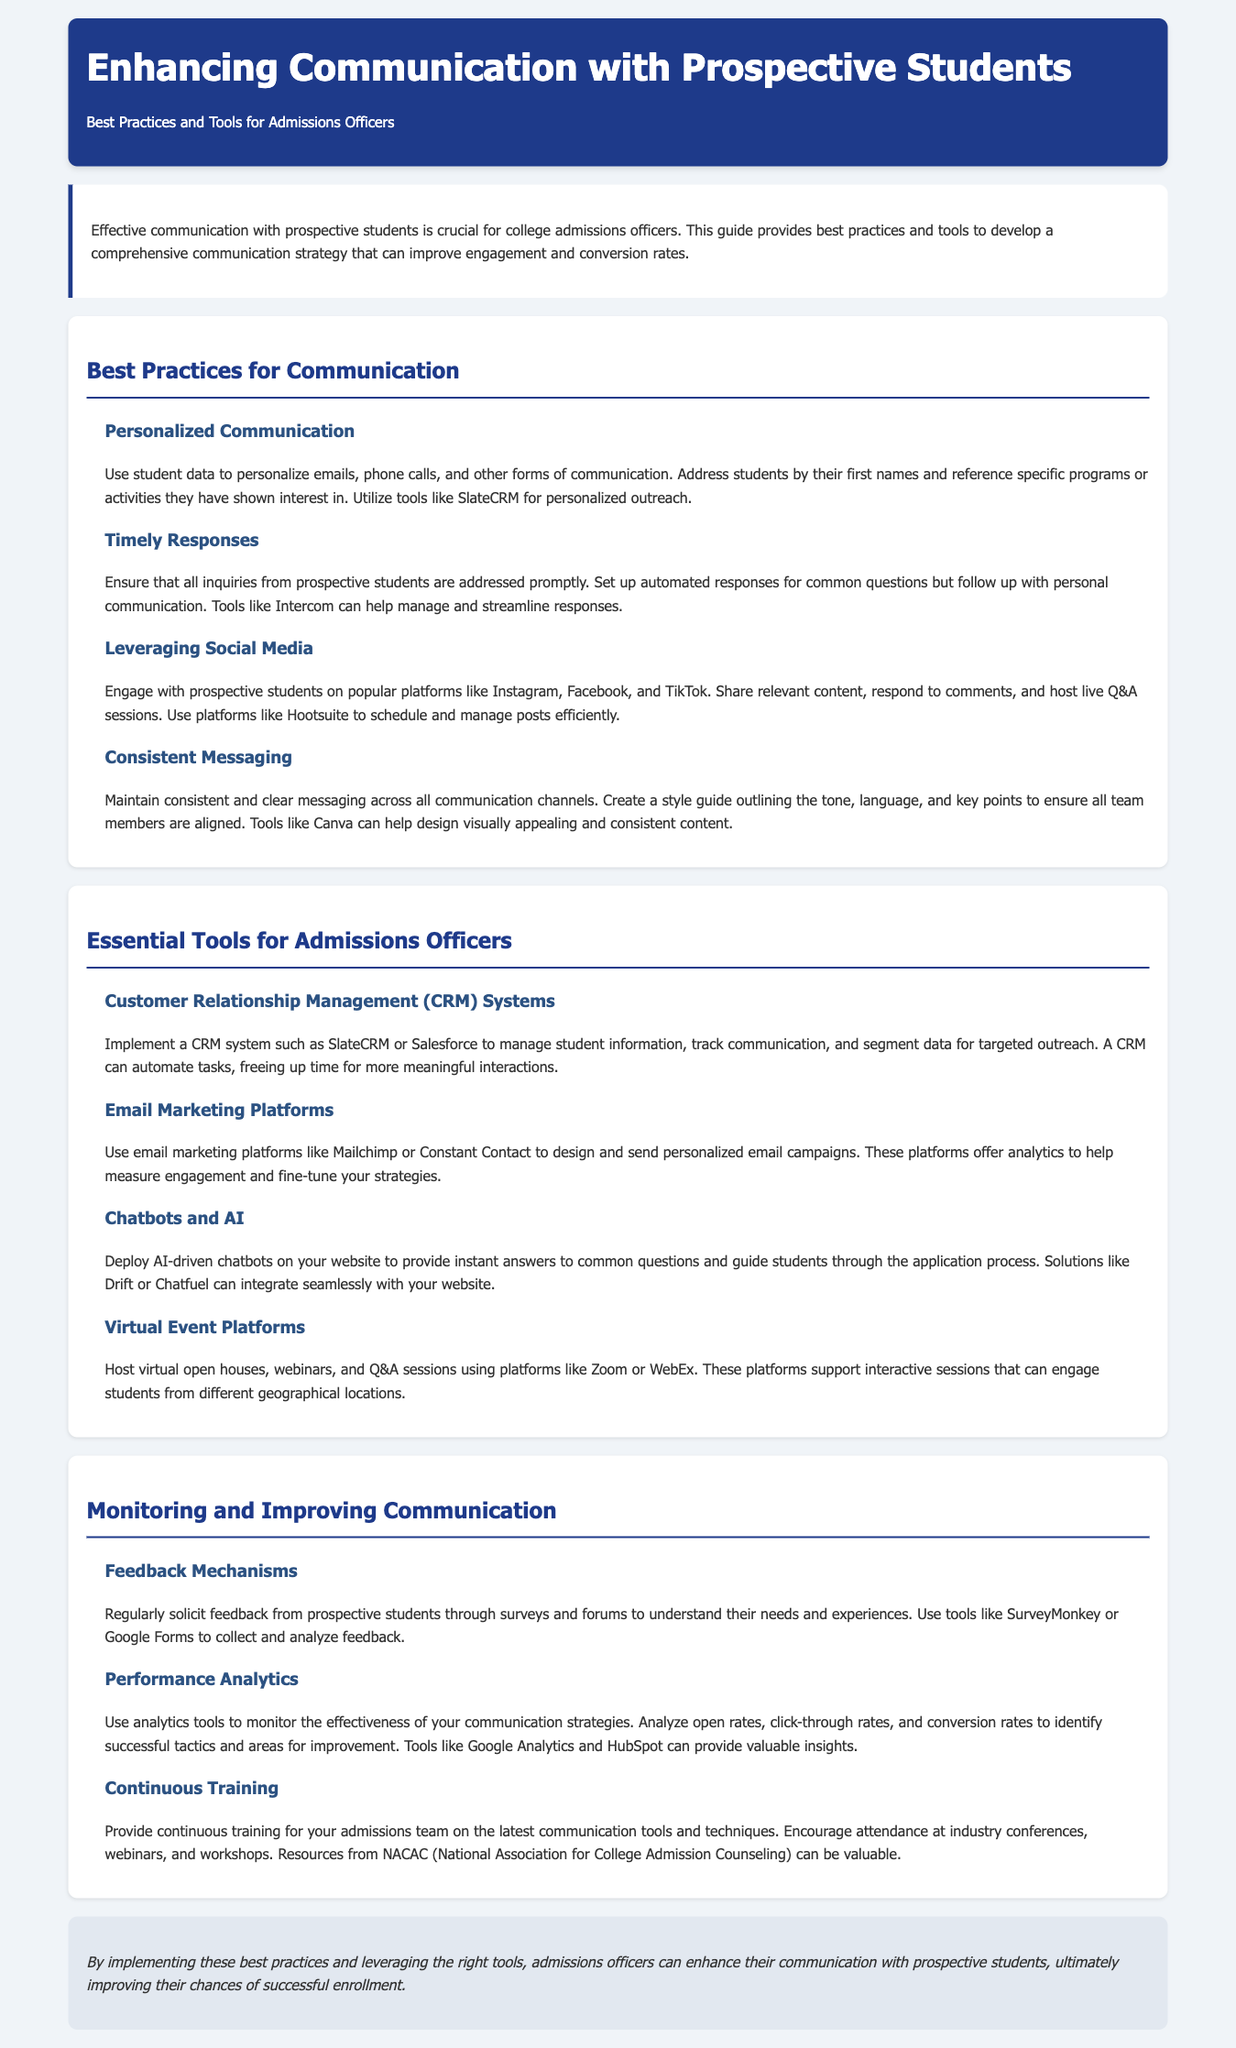what is the title of the document? The title of the document is mentioned in the header section and is "Enhancing Communication with Prospective Students".
Answer: Enhancing Communication with Prospective Students what is one tool recommended for personalized communication? The document lists specific tools under different sections, and SlateCRM is mentioned for personalized outreach.
Answer: SlateCRM which social media platforms are suggested for engagement? The document refers to Instagram, Facebook, and TikTok as popular platforms for engaging with prospective students.
Answer: Instagram, Facebook, TikTok what type of system is recommended for managing student information? Under the tools section, a CRM system is suggested for managing student information. The example given is SlateCRM or Salesforce.
Answer: CRM system what is the main focus of the feedback mechanisms mentioned? The feedback mechanisms aim to solicit regular feedback from prospective students to understand their needs and experiences.
Answer: Solicit feedback why should admissions officers maintain consistent messaging? Consistent messaging ensures that all communication channels are aligned with a clear style guide, providing a unified experience for prospective students.
Answer: Unified experience which email marketing platforms are mentioned in the document? The document includes Mailchimp and Constant Contact as examples of email marketing platforms to send personalized campaigns.
Answer: Mailchimp, Constant Contact what is one analytics tool suggested for performance monitoring? Google Analytics is mentioned in the document as a tool to monitor the effectiveness of communication strategies.
Answer: Google Analytics how should admissions teams improve their skills according to the document? The document suggests providing continuous training on the latest communication tools and techniques for admissions teams.
Answer: Continuous training 